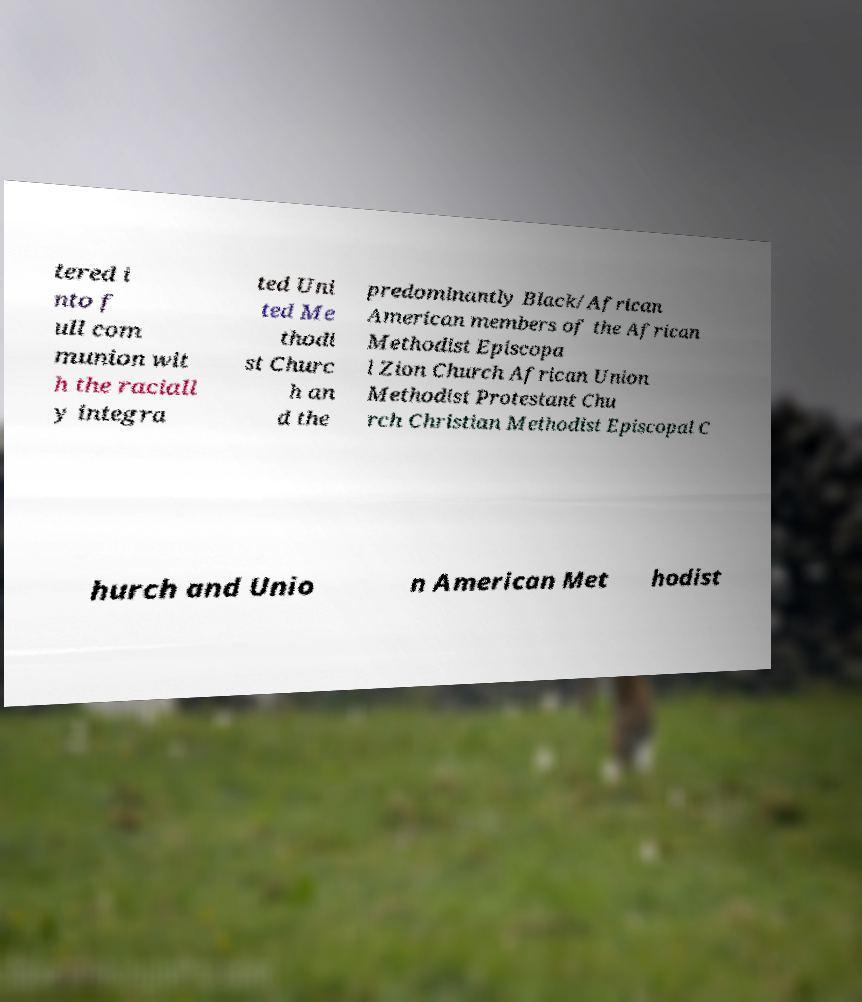Can you read and provide the text displayed in the image?This photo seems to have some interesting text. Can you extract and type it out for me? tered i nto f ull com munion wit h the raciall y integra ted Uni ted Me thodi st Churc h an d the predominantly Black/African American members of the African Methodist Episcopa l Zion Church African Union Methodist Protestant Chu rch Christian Methodist Episcopal C hurch and Unio n American Met hodist 